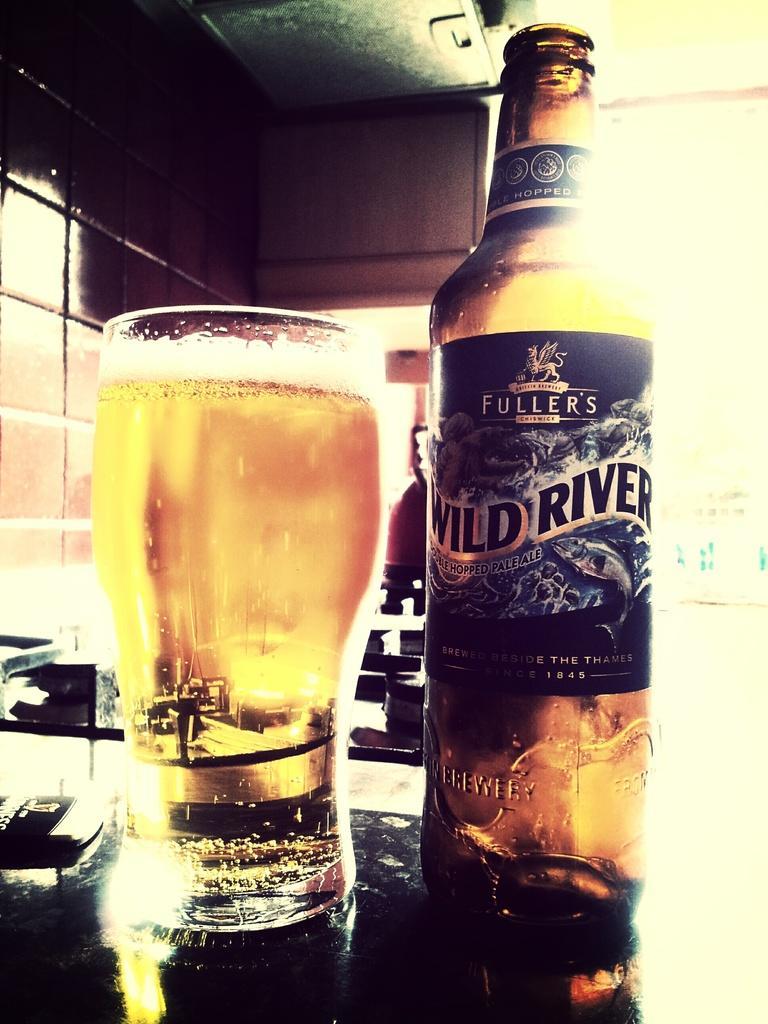Describe this image in one or two sentences. In this image we can see a bottle and a drink glass on an object. We can see the wall in the image. 